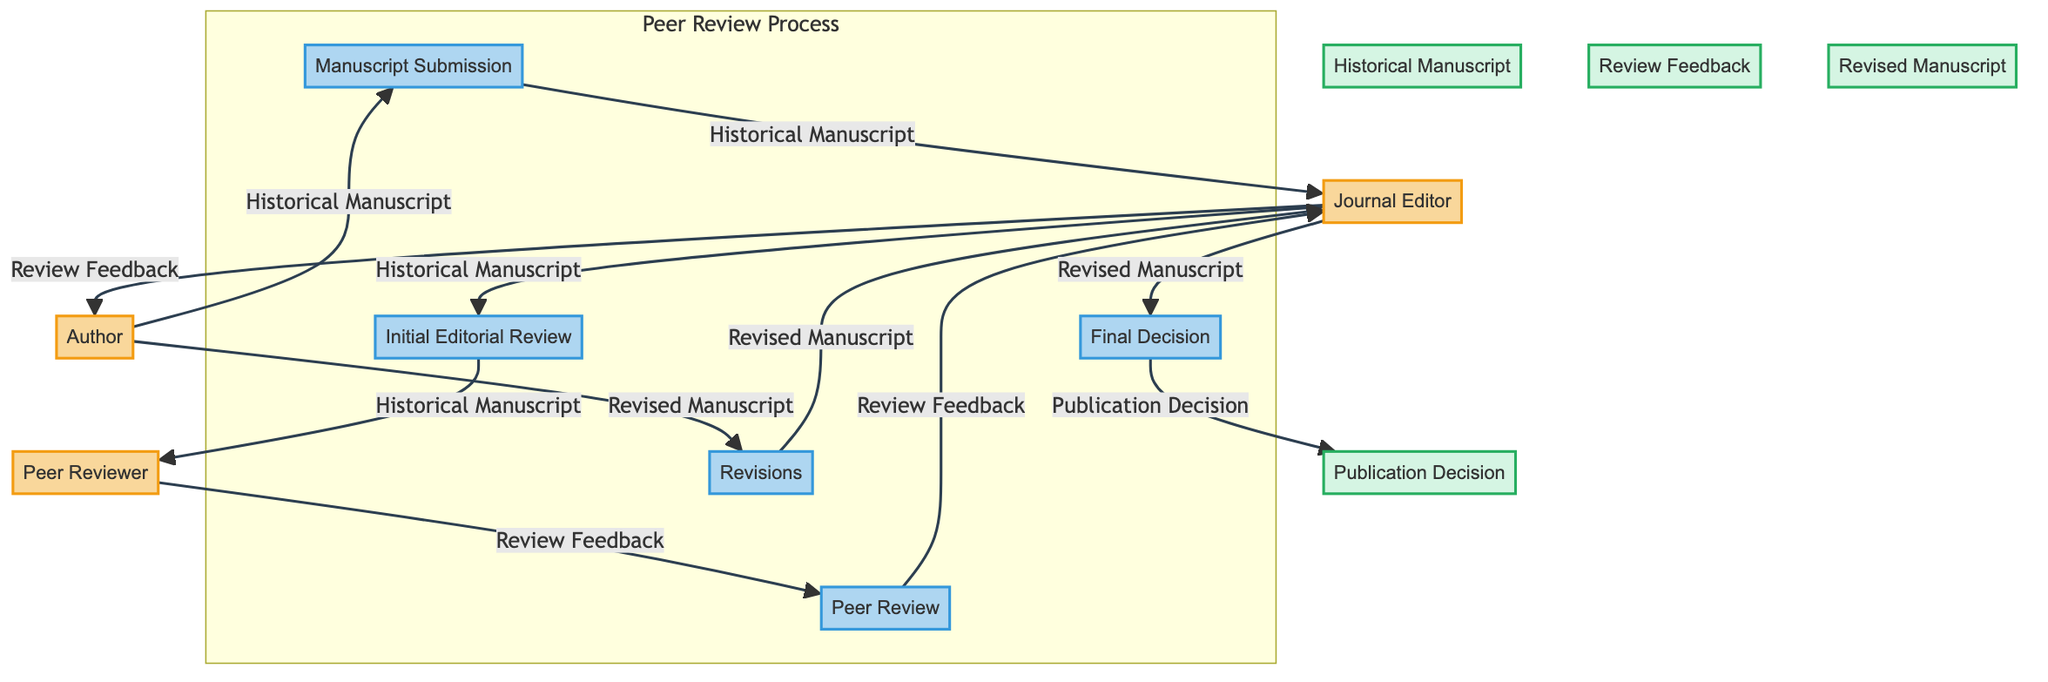What is the starting point for the peer review process? The peer review process begins with the Author who submits the Historical Manuscript. This initial step is clearly indicated by the flow from the Author to the Manuscript Submission process.
Answer: Author How many main entities are identified in the diagram? The diagram identifies six main entities: Author, Journal Editor, Peer Reviewer, Historical Manuscript, Review Feedback, and Revised Manuscript. By counting each entity, we confirm there are six present.
Answer: 6 What feedback does the Peer Reviewer provide to the Journal Editor? The Peer Reviewer provides Review Feedback to the Journal Editor. This is shown by the direct flow from the Peer Reviewer node to the Journal Editor node labeled with Review Feedback.
Answer: Review Feedback Which process follows the Initial Editorial Review? After the Initial Editorial Review process conducted by the Journal Editor, the Peer Review process takes place where Peer Reviewers evaluate the manuscript. This sequence is represented in the flow of processes.
Answer: Peer Review What is the final decision-making step in the process? The final decision-making step in the peer review process is labeled as Final Decision, where the Journal Editor makes the publication decision based on the Revised Manuscript. This step comes after several revisions have been completed.
Answer: Final Decision What does the Author submit after receiving feedback? After receiving Review Feedback from the Journal Editor, the Author submits a Revised Manuscript that incorporates the feedback provided. This submission is represented as an output from the Author back to the Journal Editor.
Answer: Revised Manuscript How are the Review Feedback comments communicated to the Author? The Review Feedback comments are communicated to the Author through a direct flow from the Journal Editor, who acts as the intermediary, sending the feedback received from the Peer Reviewer. This is explicitly shown in the diagram.
Answer: Review Feedback What action takes place after the Author submits the Revised Manuscript? Following the submission of the Revised Manuscript by the Author, the Journal Editor makes a Final Decision regarding publication. This action is represented as the next process in the diagram.
Answer: Final Decision 